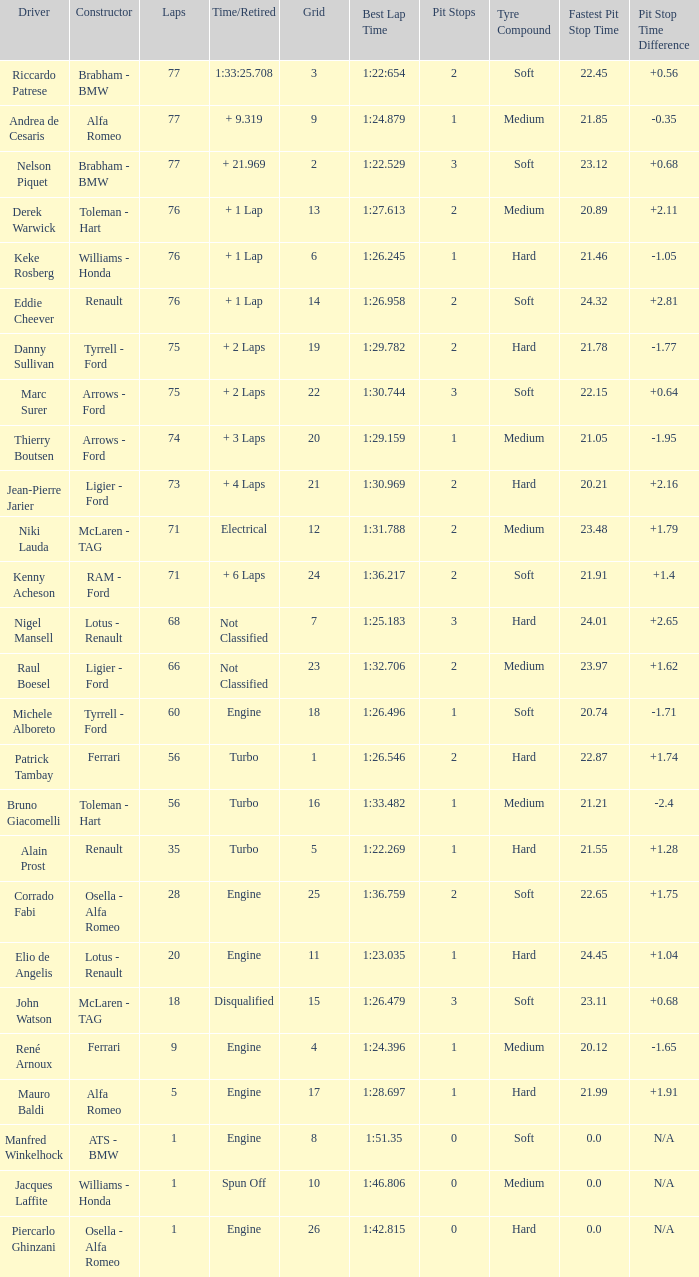Who drove the grid 10 car? Jacques Laffite. 